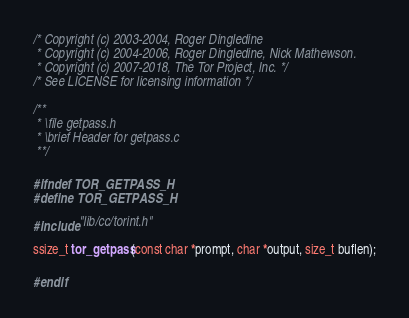Convert code to text. <code><loc_0><loc_0><loc_500><loc_500><_C_>/* Copyright (c) 2003-2004, Roger Dingledine
 * Copyright (c) 2004-2006, Roger Dingledine, Nick Mathewson.
 * Copyright (c) 2007-2018, The Tor Project, Inc. */
/* See LICENSE for licensing information */

/**
 * \file getpass.h
 * \brief Header for getpass.c
 **/

#ifndef TOR_GETPASS_H
#define TOR_GETPASS_H

#include "lib/cc/torint.h"

ssize_t tor_getpass(const char *prompt, char *output, size_t buflen);

#endif
</code> 